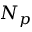<formula> <loc_0><loc_0><loc_500><loc_500>N _ { p }</formula> 